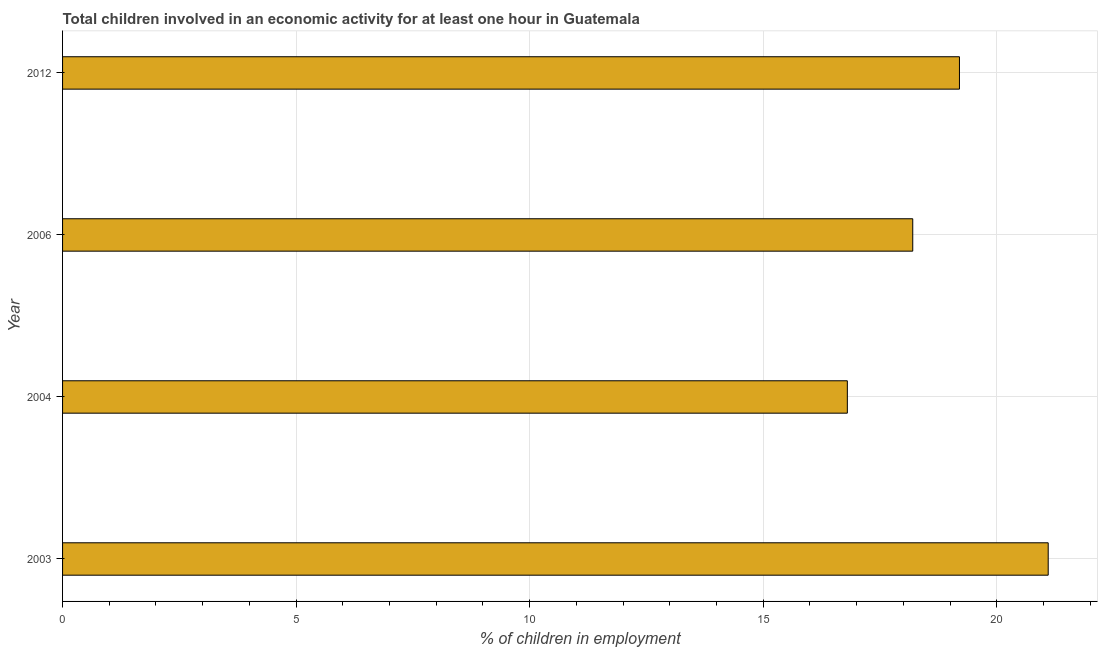Does the graph contain any zero values?
Offer a terse response. No. Does the graph contain grids?
Ensure brevity in your answer.  Yes. What is the title of the graph?
Give a very brief answer. Total children involved in an economic activity for at least one hour in Guatemala. What is the label or title of the X-axis?
Offer a terse response. % of children in employment. What is the percentage of children in employment in 2003?
Provide a short and direct response. 21.1. Across all years, what is the maximum percentage of children in employment?
Your answer should be compact. 21.1. In which year was the percentage of children in employment maximum?
Your answer should be compact. 2003. In which year was the percentage of children in employment minimum?
Offer a terse response. 2004. What is the sum of the percentage of children in employment?
Ensure brevity in your answer.  75.3. What is the difference between the percentage of children in employment in 2003 and 2012?
Provide a short and direct response. 1.9. What is the average percentage of children in employment per year?
Your answer should be compact. 18.82. Do a majority of the years between 2006 and 2012 (inclusive) have percentage of children in employment greater than 15 %?
Keep it short and to the point. Yes. What is the ratio of the percentage of children in employment in 2003 to that in 2012?
Provide a short and direct response. 1.1. Is the difference between the percentage of children in employment in 2004 and 2012 greater than the difference between any two years?
Your answer should be very brief. No. Is the sum of the percentage of children in employment in 2003 and 2006 greater than the maximum percentage of children in employment across all years?
Provide a short and direct response. Yes. What is the difference between the highest and the lowest percentage of children in employment?
Ensure brevity in your answer.  4.3. How many years are there in the graph?
Give a very brief answer. 4. Are the values on the major ticks of X-axis written in scientific E-notation?
Your answer should be compact. No. What is the % of children in employment in 2003?
Offer a very short reply. 21.1. What is the % of children in employment of 2006?
Give a very brief answer. 18.2. What is the difference between the % of children in employment in 2003 and 2012?
Your answer should be compact. 1.9. What is the ratio of the % of children in employment in 2003 to that in 2004?
Provide a succinct answer. 1.26. What is the ratio of the % of children in employment in 2003 to that in 2006?
Your response must be concise. 1.16. What is the ratio of the % of children in employment in 2003 to that in 2012?
Your answer should be compact. 1.1. What is the ratio of the % of children in employment in 2004 to that in 2006?
Offer a terse response. 0.92. What is the ratio of the % of children in employment in 2004 to that in 2012?
Provide a succinct answer. 0.88. What is the ratio of the % of children in employment in 2006 to that in 2012?
Ensure brevity in your answer.  0.95. 